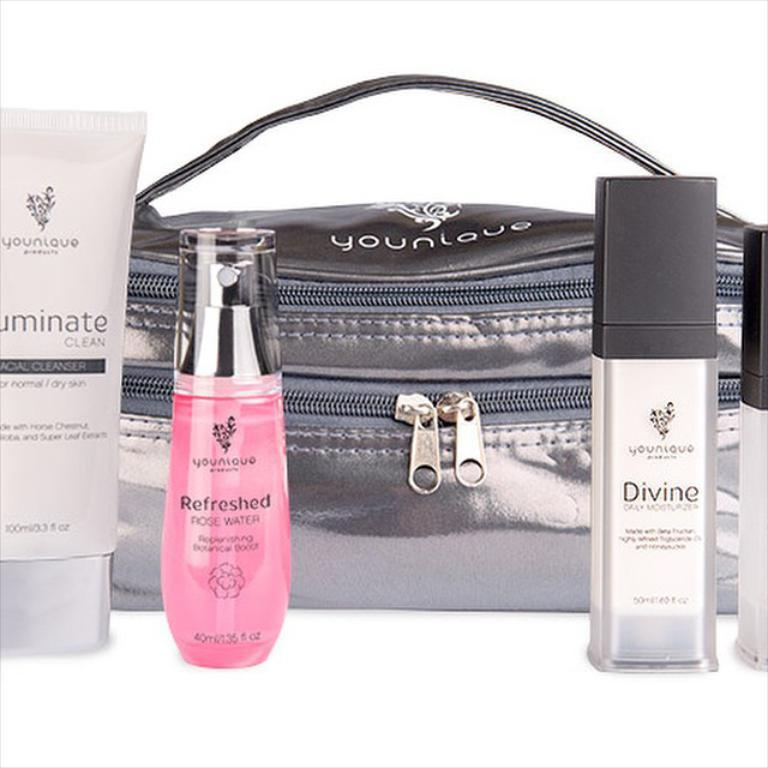<image>
Provide a brief description of the given image. Different beauty products, including a bottle of pink Refreshed, are on a table. 